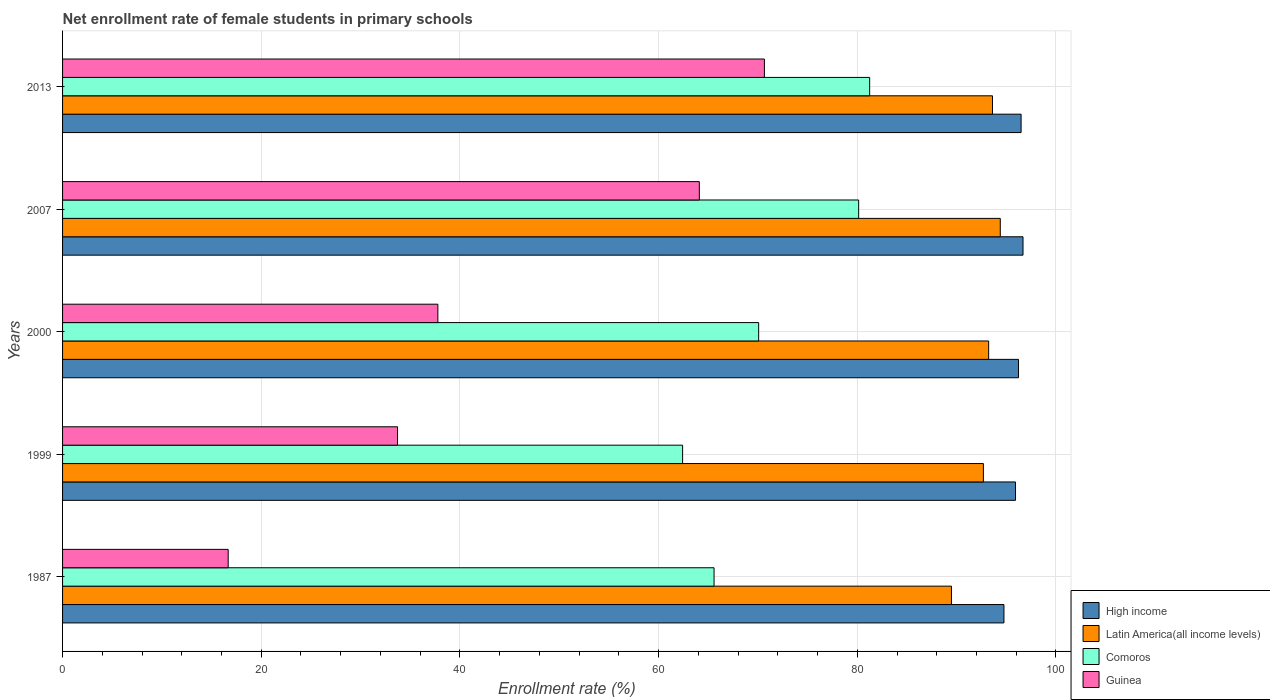How many groups of bars are there?
Provide a short and direct response. 5. Are the number of bars per tick equal to the number of legend labels?
Your answer should be compact. Yes. How many bars are there on the 1st tick from the top?
Provide a succinct answer. 4. What is the label of the 2nd group of bars from the top?
Offer a very short reply. 2007. In how many cases, is the number of bars for a given year not equal to the number of legend labels?
Keep it short and to the point. 0. What is the net enrollment rate of female students in primary schools in Guinea in 1999?
Ensure brevity in your answer.  33.72. Across all years, what is the maximum net enrollment rate of female students in primary schools in High income?
Offer a terse response. 96.68. Across all years, what is the minimum net enrollment rate of female students in primary schools in Comoros?
Provide a short and direct response. 62.42. What is the total net enrollment rate of female students in primary schools in High income in the graph?
Your answer should be very brief. 480.09. What is the difference between the net enrollment rate of female students in primary schools in Comoros in 2000 and that in 2007?
Your answer should be very brief. -10.07. What is the difference between the net enrollment rate of female students in primary schools in Guinea in 1987 and the net enrollment rate of female students in primary schools in Latin America(all income levels) in 1999?
Your answer should be compact. -76.02. What is the average net enrollment rate of female students in primary schools in Guinea per year?
Ensure brevity in your answer.  44.58. In the year 2007, what is the difference between the net enrollment rate of female students in primary schools in Comoros and net enrollment rate of female students in primary schools in Guinea?
Offer a terse response. 16.04. What is the ratio of the net enrollment rate of female students in primary schools in Latin America(all income levels) in 2000 to that in 2007?
Your response must be concise. 0.99. Is the net enrollment rate of female students in primary schools in Comoros in 1987 less than that in 1999?
Your response must be concise. No. Is the difference between the net enrollment rate of female students in primary schools in Comoros in 2000 and 2007 greater than the difference between the net enrollment rate of female students in primary schools in Guinea in 2000 and 2007?
Give a very brief answer. Yes. What is the difference between the highest and the second highest net enrollment rate of female students in primary schools in High income?
Your response must be concise. 0.19. What is the difference between the highest and the lowest net enrollment rate of female students in primary schools in Latin America(all income levels)?
Provide a short and direct response. 4.92. In how many years, is the net enrollment rate of female students in primary schools in Latin America(all income levels) greater than the average net enrollment rate of female students in primary schools in Latin America(all income levels) taken over all years?
Make the answer very short. 4. Is the sum of the net enrollment rate of female students in primary schools in Comoros in 1987 and 2000 greater than the maximum net enrollment rate of female students in primary schools in Latin America(all income levels) across all years?
Ensure brevity in your answer.  Yes. Is it the case that in every year, the sum of the net enrollment rate of female students in primary schools in Latin America(all income levels) and net enrollment rate of female students in primary schools in Comoros is greater than the sum of net enrollment rate of female students in primary schools in Guinea and net enrollment rate of female students in primary schools in High income?
Ensure brevity in your answer.  Yes. What does the 1st bar from the top in 2000 represents?
Make the answer very short. Guinea. What does the 2nd bar from the bottom in 1999 represents?
Give a very brief answer. Latin America(all income levels). Is it the case that in every year, the sum of the net enrollment rate of female students in primary schools in Guinea and net enrollment rate of female students in primary schools in High income is greater than the net enrollment rate of female students in primary schools in Latin America(all income levels)?
Your answer should be very brief. Yes. What is the difference between two consecutive major ticks on the X-axis?
Ensure brevity in your answer.  20. Where does the legend appear in the graph?
Offer a terse response. Bottom right. What is the title of the graph?
Offer a terse response. Net enrollment rate of female students in primary schools. What is the label or title of the X-axis?
Keep it short and to the point. Enrollment rate (%). What is the label or title of the Y-axis?
Offer a terse response. Years. What is the Enrollment rate (%) of High income in 1987?
Your answer should be compact. 94.76. What is the Enrollment rate (%) of Latin America(all income levels) in 1987?
Offer a terse response. 89.48. What is the Enrollment rate (%) in Comoros in 1987?
Provide a succinct answer. 65.58. What is the Enrollment rate (%) in Guinea in 1987?
Ensure brevity in your answer.  16.67. What is the Enrollment rate (%) in High income in 1999?
Provide a succinct answer. 95.93. What is the Enrollment rate (%) in Latin America(all income levels) in 1999?
Provide a short and direct response. 92.69. What is the Enrollment rate (%) in Comoros in 1999?
Keep it short and to the point. 62.42. What is the Enrollment rate (%) in Guinea in 1999?
Ensure brevity in your answer.  33.72. What is the Enrollment rate (%) in High income in 2000?
Your answer should be very brief. 96.23. What is the Enrollment rate (%) in Latin America(all income levels) in 2000?
Your answer should be very brief. 93.22. What is the Enrollment rate (%) in Comoros in 2000?
Your response must be concise. 70.07. What is the Enrollment rate (%) in Guinea in 2000?
Offer a terse response. 37.78. What is the Enrollment rate (%) of High income in 2007?
Provide a short and direct response. 96.68. What is the Enrollment rate (%) of Latin America(all income levels) in 2007?
Offer a very short reply. 94.39. What is the Enrollment rate (%) of Comoros in 2007?
Provide a succinct answer. 80.14. What is the Enrollment rate (%) of Guinea in 2007?
Provide a succinct answer. 64.1. What is the Enrollment rate (%) of High income in 2013?
Keep it short and to the point. 96.49. What is the Enrollment rate (%) in Latin America(all income levels) in 2013?
Your answer should be very brief. 93.61. What is the Enrollment rate (%) of Comoros in 2013?
Give a very brief answer. 81.24. What is the Enrollment rate (%) in Guinea in 2013?
Keep it short and to the point. 70.65. Across all years, what is the maximum Enrollment rate (%) in High income?
Provide a succinct answer. 96.68. Across all years, what is the maximum Enrollment rate (%) in Latin America(all income levels)?
Your response must be concise. 94.39. Across all years, what is the maximum Enrollment rate (%) of Comoros?
Make the answer very short. 81.24. Across all years, what is the maximum Enrollment rate (%) of Guinea?
Offer a very short reply. 70.65. Across all years, what is the minimum Enrollment rate (%) of High income?
Keep it short and to the point. 94.76. Across all years, what is the minimum Enrollment rate (%) in Latin America(all income levels)?
Keep it short and to the point. 89.48. Across all years, what is the minimum Enrollment rate (%) in Comoros?
Ensure brevity in your answer.  62.42. Across all years, what is the minimum Enrollment rate (%) in Guinea?
Give a very brief answer. 16.67. What is the total Enrollment rate (%) in High income in the graph?
Keep it short and to the point. 480.09. What is the total Enrollment rate (%) in Latin America(all income levels) in the graph?
Your answer should be compact. 463.39. What is the total Enrollment rate (%) in Comoros in the graph?
Give a very brief answer. 359.45. What is the total Enrollment rate (%) of Guinea in the graph?
Your response must be concise. 222.92. What is the difference between the Enrollment rate (%) of High income in 1987 and that in 1999?
Offer a very short reply. -1.16. What is the difference between the Enrollment rate (%) of Latin America(all income levels) in 1987 and that in 1999?
Give a very brief answer. -3.22. What is the difference between the Enrollment rate (%) of Comoros in 1987 and that in 1999?
Offer a terse response. 3.17. What is the difference between the Enrollment rate (%) in Guinea in 1987 and that in 1999?
Give a very brief answer. -17.05. What is the difference between the Enrollment rate (%) of High income in 1987 and that in 2000?
Your answer should be compact. -1.47. What is the difference between the Enrollment rate (%) in Latin America(all income levels) in 1987 and that in 2000?
Your answer should be very brief. -3.75. What is the difference between the Enrollment rate (%) of Comoros in 1987 and that in 2000?
Offer a terse response. -4.49. What is the difference between the Enrollment rate (%) in Guinea in 1987 and that in 2000?
Ensure brevity in your answer.  -21.11. What is the difference between the Enrollment rate (%) of High income in 1987 and that in 2007?
Provide a short and direct response. -1.92. What is the difference between the Enrollment rate (%) of Latin America(all income levels) in 1987 and that in 2007?
Provide a succinct answer. -4.92. What is the difference between the Enrollment rate (%) in Comoros in 1987 and that in 2007?
Provide a short and direct response. -14.56. What is the difference between the Enrollment rate (%) in Guinea in 1987 and that in 2007?
Ensure brevity in your answer.  -47.43. What is the difference between the Enrollment rate (%) of High income in 1987 and that in 2013?
Provide a succinct answer. -1.73. What is the difference between the Enrollment rate (%) of Latin America(all income levels) in 1987 and that in 2013?
Provide a short and direct response. -4.13. What is the difference between the Enrollment rate (%) of Comoros in 1987 and that in 2013?
Ensure brevity in your answer.  -15.66. What is the difference between the Enrollment rate (%) in Guinea in 1987 and that in 2013?
Ensure brevity in your answer.  -53.98. What is the difference between the Enrollment rate (%) of High income in 1999 and that in 2000?
Ensure brevity in your answer.  -0.3. What is the difference between the Enrollment rate (%) of Latin America(all income levels) in 1999 and that in 2000?
Provide a succinct answer. -0.53. What is the difference between the Enrollment rate (%) in Comoros in 1999 and that in 2000?
Your answer should be very brief. -7.66. What is the difference between the Enrollment rate (%) of Guinea in 1999 and that in 2000?
Offer a terse response. -4.06. What is the difference between the Enrollment rate (%) in High income in 1999 and that in 2007?
Your answer should be very brief. -0.76. What is the difference between the Enrollment rate (%) of Latin America(all income levels) in 1999 and that in 2007?
Ensure brevity in your answer.  -1.7. What is the difference between the Enrollment rate (%) of Comoros in 1999 and that in 2007?
Provide a short and direct response. -17.72. What is the difference between the Enrollment rate (%) of Guinea in 1999 and that in 2007?
Your answer should be compact. -30.38. What is the difference between the Enrollment rate (%) of High income in 1999 and that in 2013?
Your answer should be compact. -0.56. What is the difference between the Enrollment rate (%) of Latin America(all income levels) in 1999 and that in 2013?
Keep it short and to the point. -0.92. What is the difference between the Enrollment rate (%) of Comoros in 1999 and that in 2013?
Offer a very short reply. -18.83. What is the difference between the Enrollment rate (%) in Guinea in 1999 and that in 2013?
Keep it short and to the point. -36.93. What is the difference between the Enrollment rate (%) of High income in 2000 and that in 2007?
Offer a terse response. -0.45. What is the difference between the Enrollment rate (%) in Latin America(all income levels) in 2000 and that in 2007?
Your response must be concise. -1.17. What is the difference between the Enrollment rate (%) of Comoros in 2000 and that in 2007?
Offer a terse response. -10.07. What is the difference between the Enrollment rate (%) in Guinea in 2000 and that in 2007?
Your answer should be very brief. -26.32. What is the difference between the Enrollment rate (%) in High income in 2000 and that in 2013?
Your response must be concise. -0.26. What is the difference between the Enrollment rate (%) in Latin America(all income levels) in 2000 and that in 2013?
Give a very brief answer. -0.39. What is the difference between the Enrollment rate (%) of Comoros in 2000 and that in 2013?
Give a very brief answer. -11.17. What is the difference between the Enrollment rate (%) of Guinea in 2000 and that in 2013?
Give a very brief answer. -32.87. What is the difference between the Enrollment rate (%) of High income in 2007 and that in 2013?
Make the answer very short. 0.19. What is the difference between the Enrollment rate (%) of Latin America(all income levels) in 2007 and that in 2013?
Provide a short and direct response. 0.78. What is the difference between the Enrollment rate (%) in Comoros in 2007 and that in 2013?
Give a very brief answer. -1.11. What is the difference between the Enrollment rate (%) of Guinea in 2007 and that in 2013?
Ensure brevity in your answer.  -6.55. What is the difference between the Enrollment rate (%) of High income in 1987 and the Enrollment rate (%) of Latin America(all income levels) in 1999?
Ensure brevity in your answer.  2.07. What is the difference between the Enrollment rate (%) of High income in 1987 and the Enrollment rate (%) of Comoros in 1999?
Provide a succinct answer. 32.35. What is the difference between the Enrollment rate (%) in High income in 1987 and the Enrollment rate (%) in Guinea in 1999?
Make the answer very short. 61.05. What is the difference between the Enrollment rate (%) in Latin America(all income levels) in 1987 and the Enrollment rate (%) in Comoros in 1999?
Make the answer very short. 27.06. What is the difference between the Enrollment rate (%) in Latin America(all income levels) in 1987 and the Enrollment rate (%) in Guinea in 1999?
Your answer should be compact. 55.76. What is the difference between the Enrollment rate (%) of Comoros in 1987 and the Enrollment rate (%) of Guinea in 1999?
Give a very brief answer. 31.86. What is the difference between the Enrollment rate (%) of High income in 1987 and the Enrollment rate (%) of Latin America(all income levels) in 2000?
Make the answer very short. 1.54. What is the difference between the Enrollment rate (%) in High income in 1987 and the Enrollment rate (%) in Comoros in 2000?
Your response must be concise. 24.69. What is the difference between the Enrollment rate (%) of High income in 1987 and the Enrollment rate (%) of Guinea in 2000?
Ensure brevity in your answer.  56.98. What is the difference between the Enrollment rate (%) of Latin America(all income levels) in 1987 and the Enrollment rate (%) of Comoros in 2000?
Ensure brevity in your answer.  19.41. What is the difference between the Enrollment rate (%) in Latin America(all income levels) in 1987 and the Enrollment rate (%) in Guinea in 2000?
Provide a short and direct response. 51.7. What is the difference between the Enrollment rate (%) in Comoros in 1987 and the Enrollment rate (%) in Guinea in 2000?
Your response must be concise. 27.8. What is the difference between the Enrollment rate (%) in High income in 1987 and the Enrollment rate (%) in Latin America(all income levels) in 2007?
Your answer should be very brief. 0.37. What is the difference between the Enrollment rate (%) of High income in 1987 and the Enrollment rate (%) of Comoros in 2007?
Ensure brevity in your answer.  14.63. What is the difference between the Enrollment rate (%) in High income in 1987 and the Enrollment rate (%) in Guinea in 2007?
Your response must be concise. 30.67. What is the difference between the Enrollment rate (%) of Latin America(all income levels) in 1987 and the Enrollment rate (%) of Comoros in 2007?
Your answer should be very brief. 9.34. What is the difference between the Enrollment rate (%) of Latin America(all income levels) in 1987 and the Enrollment rate (%) of Guinea in 2007?
Ensure brevity in your answer.  25.38. What is the difference between the Enrollment rate (%) of Comoros in 1987 and the Enrollment rate (%) of Guinea in 2007?
Your answer should be very brief. 1.48. What is the difference between the Enrollment rate (%) in High income in 1987 and the Enrollment rate (%) in Latin America(all income levels) in 2013?
Give a very brief answer. 1.15. What is the difference between the Enrollment rate (%) in High income in 1987 and the Enrollment rate (%) in Comoros in 2013?
Provide a succinct answer. 13.52. What is the difference between the Enrollment rate (%) of High income in 1987 and the Enrollment rate (%) of Guinea in 2013?
Make the answer very short. 24.11. What is the difference between the Enrollment rate (%) in Latin America(all income levels) in 1987 and the Enrollment rate (%) in Comoros in 2013?
Your answer should be compact. 8.23. What is the difference between the Enrollment rate (%) in Latin America(all income levels) in 1987 and the Enrollment rate (%) in Guinea in 2013?
Offer a very short reply. 18.83. What is the difference between the Enrollment rate (%) of Comoros in 1987 and the Enrollment rate (%) of Guinea in 2013?
Make the answer very short. -5.07. What is the difference between the Enrollment rate (%) in High income in 1999 and the Enrollment rate (%) in Latin America(all income levels) in 2000?
Your response must be concise. 2.7. What is the difference between the Enrollment rate (%) in High income in 1999 and the Enrollment rate (%) in Comoros in 2000?
Give a very brief answer. 25.86. What is the difference between the Enrollment rate (%) in High income in 1999 and the Enrollment rate (%) in Guinea in 2000?
Keep it short and to the point. 58.15. What is the difference between the Enrollment rate (%) in Latin America(all income levels) in 1999 and the Enrollment rate (%) in Comoros in 2000?
Make the answer very short. 22.62. What is the difference between the Enrollment rate (%) in Latin America(all income levels) in 1999 and the Enrollment rate (%) in Guinea in 2000?
Provide a succinct answer. 54.91. What is the difference between the Enrollment rate (%) in Comoros in 1999 and the Enrollment rate (%) in Guinea in 2000?
Your answer should be compact. 24.64. What is the difference between the Enrollment rate (%) in High income in 1999 and the Enrollment rate (%) in Latin America(all income levels) in 2007?
Your answer should be compact. 1.53. What is the difference between the Enrollment rate (%) of High income in 1999 and the Enrollment rate (%) of Comoros in 2007?
Give a very brief answer. 15.79. What is the difference between the Enrollment rate (%) of High income in 1999 and the Enrollment rate (%) of Guinea in 2007?
Give a very brief answer. 31.83. What is the difference between the Enrollment rate (%) of Latin America(all income levels) in 1999 and the Enrollment rate (%) of Comoros in 2007?
Your answer should be compact. 12.56. What is the difference between the Enrollment rate (%) of Latin America(all income levels) in 1999 and the Enrollment rate (%) of Guinea in 2007?
Ensure brevity in your answer.  28.6. What is the difference between the Enrollment rate (%) in Comoros in 1999 and the Enrollment rate (%) in Guinea in 2007?
Offer a very short reply. -1.68. What is the difference between the Enrollment rate (%) in High income in 1999 and the Enrollment rate (%) in Latin America(all income levels) in 2013?
Give a very brief answer. 2.32. What is the difference between the Enrollment rate (%) of High income in 1999 and the Enrollment rate (%) of Comoros in 2013?
Provide a succinct answer. 14.68. What is the difference between the Enrollment rate (%) in High income in 1999 and the Enrollment rate (%) in Guinea in 2013?
Your response must be concise. 25.28. What is the difference between the Enrollment rate (%) of Latin America(all income levels) in 1999 and the Enrollment rate (%) of Comoros in 2013?
Your response must be concise. 11.45. What is the difference between the Enrollment rate (%) of Latin America(all income levels) in 1999 and the Enrollment rate (%) of Guinea in 2013?
Offer a very short reply. 22.04. What is the difference between the Enrollment rate (%) of Comoros in 1999 and the Enrollment rate (%) of Guinea in 2013?
Give a very brief answer. -8.23. What is the difference between the Enrollment rate (%) of High income in 2000 and the Enrollment rate (%) of Latin America(all income levels) in 2007?
Provide a succinct answer. 1.84. What is the difference between the Enrollment rate (%) of High income in 2000 and the Enrollment rate (%) of Comoros in 2007?
Offer a very short reply. 16.09. What is the difference between the Enrollment rate (%) of High income in 2000 and the Enrollment rate (%) of Guinea in 2007?
Keep it short and to the point. 32.13. What is the difference between the Enrollment rate (%) in Latin America(all income levels) in 2000 and the Enrollment rate (%) in Comoros in 2007?
Keep it short and to the point. 13.08. What is the difference between the Enrollment rate (%) in Latin America(all income levels) in 2000 and the Enrollment rate (%) in Guinea in 2007?
Your response must be concise. 29.12. What is the difference between the Enrollment rate (%) of Comoros in 2000 and the Enrollment rate (%) of Guinea in 2007?
Ensure brevity in your answer.  5.97. What is the difference between the Enrollment rate (%) of High income in 2000 and the Enrollment rate (%) of Latin America(all income levels) in 2013?
Your answer should be very brief. 2.62. What is the difference between the Enrollment rate (%) of High income in 2000 and the Enrollment rate (%) of Comoros in 2013?
Your response must be concise. 14.98. What is the difference between the Enrollment rate (%) in High income in 2000 and the Enrollment rate (%) in Guinea in 2013?
Provide a short and direct response. 25.58. What is the difference between the Enrollment rate (%) in Latin America(all income levels) in 2000 and the Enrollment rate (%) in Comoros in 2013?
Your response must be concise. 11.98. What is the difference between the Enrollment rate (%) of Latin America(all income levels) in 2000 and the Enrollment rate (%) of Guinea in 2013?
Ensure brevity in your answer.  22.57. What is the difference between the Enrollment rate (%) of Comoros in 2000 and the Enrollment rate (%) of Guinea in 2013?
Your response must be concise. -0.58. What is the difference between the Enrollment rate (%) of High income in 2007 and the Enrollment rate (%) of Latin America(all income levels) in 2013?
Offer a very short reply. 3.07. What is the difference between the Enrollment rate (%) of High income in 2007 and the Enrollment rate (%) of Comoros in 2013?
Provide a succinct answer. 15.44. What is the difference between the Enrollment rate (%) in High income in 2007 and the Enrollment rate (%) in Guinea in 2013?
Provide a short and direct response. 26.03. What is the difference between the Enrollment rate (%) of Latin America(all income levels) in 2007 and the Enrollment rate (%) of Comoros in 2013?
Provide a succinct answer. 13.15. What is the difference between the Enrollment rate (%) in Latin America(all income levels) in 2007 and the Enrollment rate (%) in Guinea in 2013?
Provide a succinct answer. 23.74. What is the difference between the Enrollment rate (%) in Comoros in 2007 and the Enrollment rate (%) in Guinea in 2013?
Ensure brevity in your answer.  9.49. What is the average Enrollment rate (%) of High income per year?
Offer a very short reply. 96.02. What is the average Enrollment rate (%) in Latin America(all income levels) per year?
Provide a succinct answer. 92.68. What is the average Enrollment rate (%) of Comoros per year?
Keep it short and to the point. 71.89. What is the average Enrollment rate (%) of Guinea per year?
Your answer should be very brief. 44.58. In the year 1987, what is the difference between the Enrollment rate (%) in High income and Enrollment rate (%) in Latin America(all income levels)?
Your answer should be very brief. 5.29. In the year 1987, what is the difference between the Enrollment rate (%) of High income and Enrollment rate (%) of Comoros?
Offer a very short reply. 29.18. In the year 1987, what is the difference between the Enrollment rate (%) of High income and Enrollment rate (%) of Guinea?
Provide a short and direct response. 78.09. In the year 1987, what is the difference between the Enrollment rate (%) of Latin America(all income levels) and Enrollment rate (%) of Comoros?
Offer a very short reply. 23.9. In the year 1987, what is the difference between the Enrollment rate (%) of Latin America(all income levels) and Enrollment rate (%) of Guinea?
Provide a succinct answer. 72.81. In the year 1987, what is the difference between the Enrollment rate (%) of Comoros and Enrollment rate (%) of Guinea?
Offer a terse response. 48.91. In the year 1999, what is the difference between the Enrollment rate (%) of High income and Enrollment rate (%) of Latin America(all income levels)?
Keep it short and to the point. 3.23. In the year 1999, what is the difference between the Enrollment rate (%) in High income and Enrollment rate (%) in Comoros?
Your response must be concise. 33.51. In the year 1999, what is the difference between the Enrollment rate (%) of High income and Enrollment rate (%) of Guinea?
Offer a very short reply. 62.21. In the year 1999, what is the difference between the Enrollment rate (%) in Latin America(all income levels) and Enrollment rate (%) in Comoros?
Ensure brevity in your answer.  30.28. In the year 1999, what is the difference between the Enrollment rate (%) in Latin America(all income levels) and Enrollment rate (%) in Guinea?
Provide a short and direct response. 58.98. In the year 1999, what is the difference between the Enrollment rate (%) in Comoros and Enrollment rate (%) in Guinea?
Offer a very short reply. 28.7. In the year 2000, what is the difference between the Enrollment rate (%) in High income and Enrollment rate (%) in Latin America(all income levels)?
Offer a terse response. 3.01. In the year 2000, what is the difference between the Enrollment rate (%) of High income and Enrollment rate (%) of Comoros?
Offer a very short reply. 26.16. In the year 2000, what is the difference between the Enrollment rate (%) in High income and Enrollment rate (%) in Guinea?
Your answer should be compact. 58.45. In the year 2000, what is the difference between the Enrollment rate (%) in Latin America(all income levels) and Enrollment rate (%) in Comoros?
Your answer should be very brief. 23.15. In the year 2000, what is the difference between the Enrollment rate (%) in Latin America(all income levels) and Enrollment rate (%) in Guinea?
Your answer should be compact. 55.44. In the year 2000, what is the difference between the Enrollment rate (%) in Comoros and Enrollment rate (%) in Guinea?
Offer a terse response. 32.29. In the year 2007, what is the difference between the Enrollment rate (%) in High income and Enrollment rate (%) in Latin America(all income levels)?
Provide a succinct answer. 2.29. In the year 2007, what is the difference between the Enrollment rate (%) of High income and Enrollment rate (%) of Comoros?
Your answer should be very brief. 16.54. In the year 2007, what is the difference between the Enrollment rate (%) of High income and Enrollment rate (%) of Guinea?
Offer a very short reply. 32.58. In the year 2007, what is the difference between the Enrollment rate (%) of Latin America(all income levels) and Enrollment rate (%) of Comoros?
Your response must be concise. 14.26. In the year 2007, what is the difference between the Enrollment rate (%) of Latin America(all income levels) and Enrollment rate (%) of Guinea?
Offer a terse response. 30.3. In the year 2007, what is the difference between the Enrollment rate (%) in Comoros and Enrollment rate (%) in Guinea?
Ensure brevity in your answer.  16.04. In the year 2013, what is the difference between the Enrollment rate (%) of High income and Enrollment rate (%) of Latin America(all income levels)?
Your response must be concise. 2.88. In the year 2013, what is the difference between the Enrollment rate (%) of High income and Enrollment rate (%) of Comoros?
Give a very brief answer. 15.24. In the year 2013, what is the difference between the Enrollment rate (%) in High income and Enrollment rate (%) in Guinea?
Your answer should be compact. 25.84. In the year 2013, what is the difference between the Enrollment rate (%) of Latin America(all income levels) and Enrollment rate (%) of Comoros?
Keep it short and to the point. 12.36. In the year 2013, what is the difference between the Enrollment rate (%) in Latin America(all income levels) and Enrollment rate (%) in Guinea?
Make the answer very short. 22.96. In the year 2013, what is the difference between the Enrollment rate (%) in Comoros and Enrollment rate (%) in Guinea?
Provide a short and direct response. 10.59. What is the ratio of the Enrollment rate (%) in High income in 1987 to that in 1999?
Provide a short and direct response. 0.99. What is the ratio of the Enrollment rate (%) in Latin America(all income levels) in 1987 to that in 1999?
Your answer should be compact. 0.97. What is the ratio of the Enrollment rate (%) of Comoros in 1987 to that in 1999?
Your answer should be very brief. 1.05. What is the ratio of the Enrollment rate (%) of Guinea in 1987 to that in 1999?
Offer a terse response. 0.49. What is the ratio of the Enrollment rate (%) of Latin America(all income levels) in 1987 to that in 2000?
Provide a succinct answer. 0.96. What is the ratio of the Enrollment rate (%) of Comoros in 1987 to that in 2000?
Your response must be concise. 0.94. What is the ratio of the Enrollment rate (%) in Guinea in 1987 to that in 2000?
Keep it short and to the point. 0.44. What is the ratio of the Enrollment rate (%) of High income in 1987 to that in 2007?
Your answer should be very brief. 0.98. What is the ratio of the Enrollment rate (%) of Latin America(all income levels) in 1987 to that in 2007?
Offer a very short reply. 0.95. What is the ratio of the Enrollment rate (%) in Comoros in 1987 to that in 2007?
Your response must be concise. 0.82. What is the ratio of the Enrollment rate (%) in Guinea in 1987 to that in 2007?
Offer a terse response. 0.26. What is the ratio of the Enrollment rate (%) in High income in 1987 to that in 2013?
Provide a short and direct response. 0.98. What is the ratio of the Enrollment rate (%) of Latin America(all income levels) in 1987 to that in 2013?
Offer a terse response. 0.96. What is the ratio of the Enrollment rate (%) of Comoros in 1987 to that in 2013?
Offer a very short reply. 0.81. What is the ratio of the Enrollment rate (%) in Guinea in 1987 to that in 2013?
Offer a very short reply. 0.24. What is the ratio of the Enrollment rate (%) in High income in 1999 to that in 2000?
Ensure brevity in your answer.  1. What is the ratio of the Enrollment rate (%) in Comoros in 1999 to that in 2000?
Provide a short and direct response. 0.89. What is the ratio of the Enrollment rate (%) of Guinea in 1999 to that in 2000?
Keep it short and to the point. 0.89. What is the ratio of the Enrollment rate (%) in High income in 1999 to that in 2007?
Ensure brevity in your answer.  0.99. What is the ratio of the Enrollment rate (%) of Comoros in 1999 to that in 2007?
Keep it short and to the point. 0.78. What is the ratio of the Enrollment rate (%) in Guinea in 1999 to that in 2007?
Offer a very short reply. 0.53. What is the ratio of the Enrollment rate (%) in High income in 1999 to that in 2013?
Your answer should be compact. 0.99. What is the ratio of the Enrollment rate (%) of Latin America(all income levels) in 1999 to that in 2013?
Offer a terse response. 0.99. What is the ratio of the Enrollment rate (%) of Comoros in 1999 to that in 2013?
Your answer should be very brief. 0.77. What is the ratio of the Enrollment rate (%) of Guinea in 1999 to that in 2013?
Provide a short and direct response. 0.48. What is the ratio of the Enrollment rate (%) in High income in 2000 to that in 2007?
Give a very brief answer. 1. What is the ratio of the Enrollment rate (%) in Latin America(all income levels) in 2000 to that in 2007?
Offer a terse response. 0.99. What is the ratio of the Enrollment rate (%) of Comoros in 2000 to that in 2007?
Provide a short and direct response. 0.87. What is the ratio of the Enrollment rate (%) in Guinea in 2000 to that in 2007?
Provide a succinct answer. 0.59. What is the ratio of the Enrollment rate (%) in Latin America(all income levels) in 2000 to that in 2013?
Give a very brief answer. 1. What is the ratio of the Enrollment rate (%) of Comoros in 2000 to that in 2013?
Ensure brevity in your answer.  0.86. What is the ratio of the Enrollment rate (%) in Guinea in 2000 to that in 2013?
Give a very brief answer. 0.53. What is the ratio of the Enrollment rate (%) in Latin America(all income levels) in 2007 to that in 2013?
Your response must be concise. 1.01. What is the ratio of the Enrollment rate (%) in Comoros in 2007 to that in 2013?
Your answer should be very brief. 0.99. What is the ratio of the Enrollment rate (%) of Guinea in 2007 to that in 2013?
Offer a very short reply. 0.91. What is the difference between the highest and the second highest Enrollment rate (%) in High income?
Provide a succinct answer. 0.19. What is the difference between the highest and the second highest Enrollment rate (%) of Latin America(all income levels)?
Your response must be concise. 0.78. What is the difference between the highest and the second highest Enrollment rate (%) in Comoros?
Provide a succinct answer. 1.11. What is the difference between the highest and the second highest Enrollment rate (%) of Guinea?
Make the answer very short. 6.55. What is the difference between the highest and the lowest Enrollment rate (%) of High income?
Offer a very short reply. 1.92. What is the difference between the highest and the lowest Enrollment rate (%) of Latin America(all income levels)?
Make the answer very short. 4.92. What is the difference between the highest and the lowest Enrollment rate (%) in Comoros?
Offer a very short reply. 18.83. What is the difference between the highest and the lowest Enrollment rate (%) in Guinea?
Offer a terse response. 53.98. 